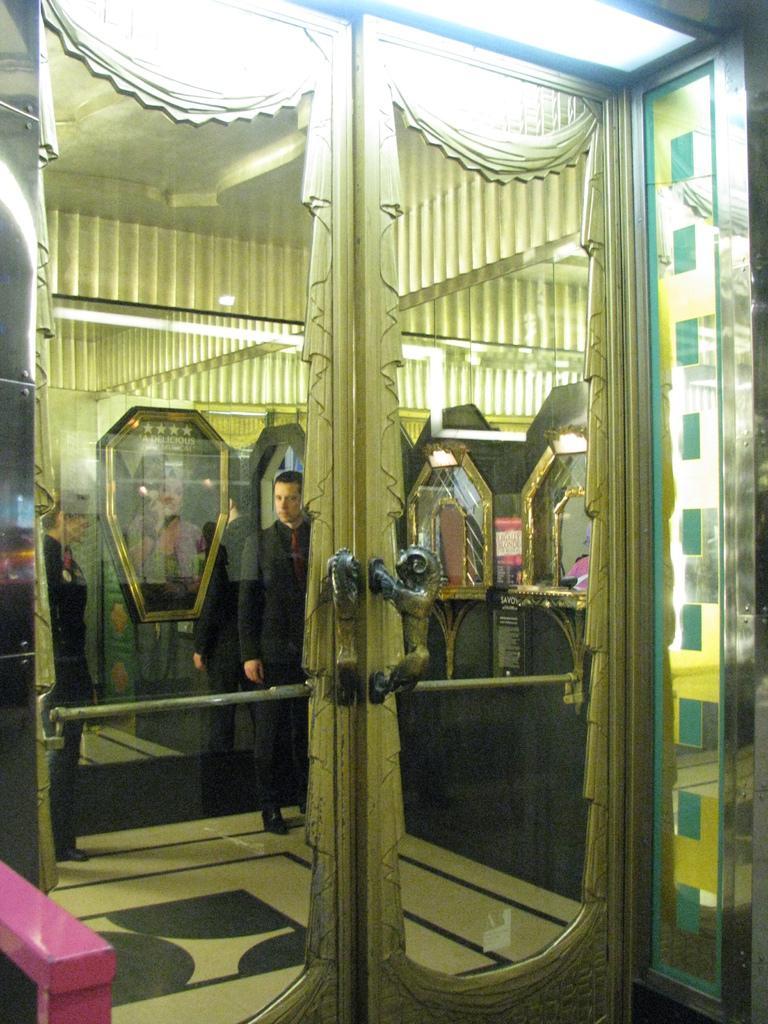Describe this image in one or two sentences. In this image, we can see glass doors with handles. Through the glass we can see the inside view. Here we can see few people, wall, light, ceiling and floor. Left side bottom corner, we can see pink color rod. 